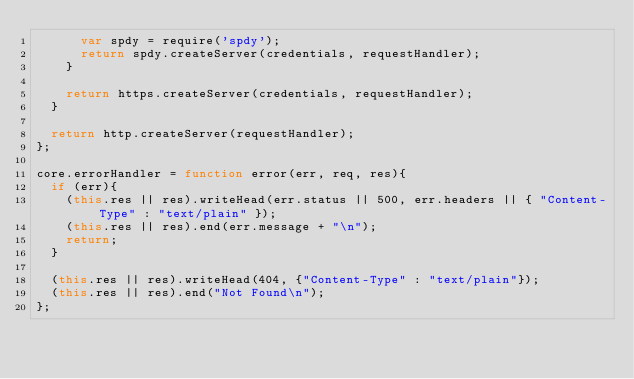<code> <loc_0><loc_0><loc_500><loc_500><_JavaScript_>      var spdy = require('spdy');
      return spdy.createServer(credentials, requestHandler);
    }

    return https.createServer(credentials, requestHandler);
  }

  return http.createServer(requestHandler);
};

core.errorHandler = function error(err, req, res){
  if (err){
    (this.res || res).writeHead(err.status || 500, err.headers || { "Content-Type" : "text/plain" });
    (this.res || res).end(err.message + "\n");
    return;
  }

  (this.res || res).writeHead(404, {"Content-Type" : "text/plain"});
  (this.res || res).end("Not Found\n");
};
</code> 